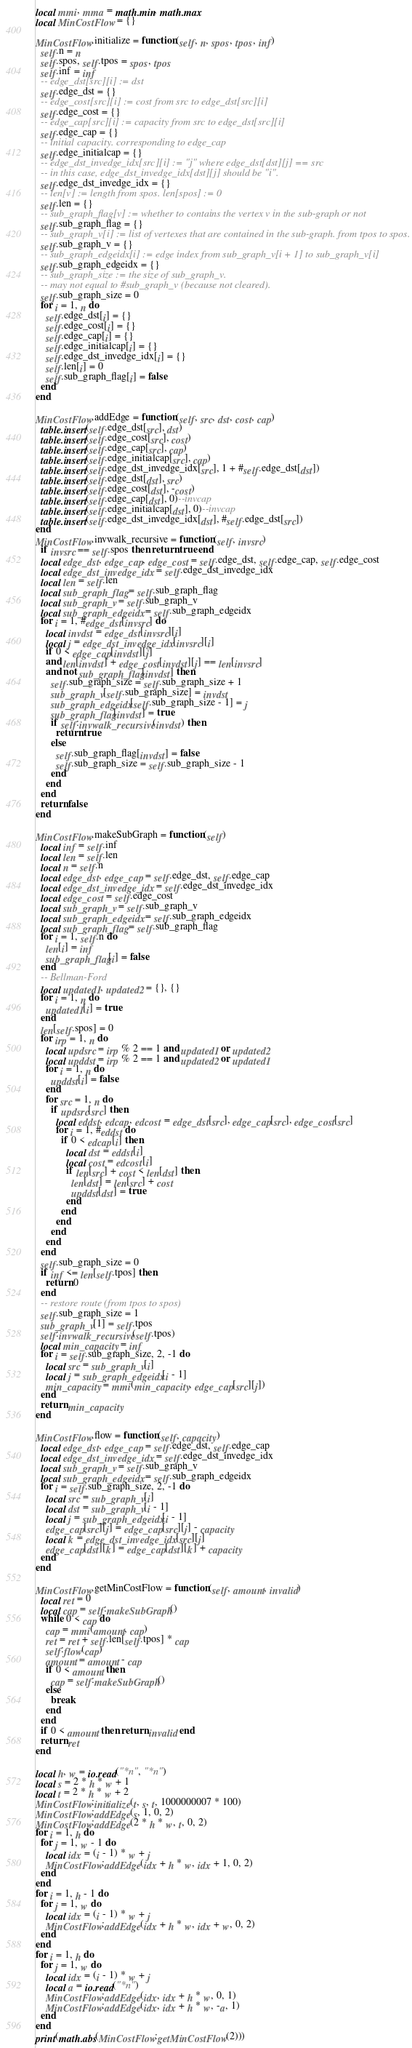<code> <loc_0><loc_0><loc_500><loc_500><_Lua_>local mmi, mma = math.min, math.max
local MinCostFlow = {}

MinCostFlow.initialize = function(self, n, spos, tpos, inf)
  self.n = n
  self.spos, self.tpos = spos, tpos
  self.inf = inf
  -- edge_dst[src][i] := dst
  self.edge_dst = {}
  -- edge_cost[src][i] := cost from src to edge_dst[src][i]
  self.edge_cost = {}
  -- edge_cap[src][i] := capacity from src to edge_dst[src][i]
  self.edge_cap = {}
  -- initial capacity. corresponding to edge_cap
  self.edge_initialcap = {}
  -- edge_dst_invedge_idx[src][i] := "j" where edge_dst[dst][j] == src
  -- in this case, edge_dst_invedge_idx[dst][j] should be "i".
  self.edge_dst_invedge_idx = {}
  -- len[v] := length from spos. len[spos] := 0
  self.len = {}
  -- sub_graph_flag[v] := whether to contains the vertex v in the sub-graph or not
  self.sub_graph_flag = {}
  -- sub_graph_v[i] := list of vertexes that are contained in the sub-graph. from tpos to spos.
  self.sub_graph_v = {}
  -- sub_graph_edgeidx[i] := edge index from sub_graph_v[i + 1] to sub_graph_v[i]
  self.sub_graph_edgeidx = {}
  -- sub_graph_size := the size of sub_graph_v.
  -- may not equal to #sub_graph_v (because not cleared).
  self.sub_graph_size = 0
  for i = 1, n do
    self.edge_dst[i] = {}
    self.edge_cost[i] = {}
    self.edge_cap[i] = {}
    self.edge_initialcap[i] = {}
    self.edge_dst_invedge_idx[i] = {}
    self.len[i] = 0
    self.sub_graph_flag[i] = false
  end
end

MinCostFlow.addEdge = function(self, src, dst, cost, cap)
  table.insert(self.edge_dst[src], dst)
  table.insert(self.edge_cost[src], cost)
  table.insert(self.edge_cap[src], cap)
  table.insert(self.edge_initialcap[src], cap)
  table.insert(self.edge_dst_invedge_idx[src], 1 + #self.edge_dst[dst])
  table.insert(self.edge_dst[dst], src)
  table.insert(self.edge_cost[dst], -cost)
  table.insert(self.edge_cap[dst], 0)--invcap
  table.insert(self.edge_initialcap[dst], 0)--invcap
  table.insert(self.edge_dst_invedge_idx[dst], #self.edge_dst[src])
end
MinCostFlow.invwalk_recursive = function(self, invsrc)
  if invsrc == self.spos then return true end
  local edge_dst, edge_cap, edge_cost = self.edge_dst, self.edge_cap, self.edge_cost
  local edge_dst_invedge_idx = self.edge_dst_invedge_idx
  local len = self.len
  local sub_graph_flag = self.sub_graph_flag
  local sub_graph_v = self.sub_graph_v
  local sub_graph_edgeidx = self.sub_graph_edgeidx
  for i = 1, #edge_dst[invsrc] do
    local invdst = edge_dst[invsrc][i]
    local j = edge_dst_invedge_idx[invsrc][i]
    if 0 < edge_cap[invdst][j]
    and len[invdst] + edge_cost[invdst][j] == len[invsrc]
    and not sub_graph_flag[invdst] then
      self.sub_graph_size = self.sub_graph_size + 1
      sub_graph_v[self.sub_graph_size] = invdst
      sub_graph_edgeidx[self.sub_graph_size - 1] = j
      sub_graph_flag[invdst] = true
      if self:invwalk_recursive(invdst) then
        return true
      else
        self.sub_graph_flag[invdst] = false
        self.sub_graph_size = self.sub_graph_size - 1
      end
    end
  end
  return false
end

MinCostFlow.makeSubGraph = function(self)
  local inf = self.inf
  local len = self.len
  local n = self.n
  local edge_dst, edge_cap = self.edge_dst, self.edge_cap
  local edge_dst_invedge_idx = self.edge_dst_invedge_idx
  local edge_cost = self.edge_cost
  local sub_graph_v = self.sub_graph_v
  local sub_graph_edgeidx = self.sub_graph_edgeidx
  local sub_graph_flag = self.sub_graph_flag
  for i = 1, self.n do
    len[i] = inf
    sub_graph_flag[i] = false
  end
  -- Bellman-Ford
  local updated1, updated2 = {}, {}
  for i = 1, n do
    updated1[i] = true
  end
  len[self.spos] = 0
  for irp = 1, n do
    local updsrc = irp % 2 == 1 and updated1 or updated2
    local upddst = irp % 2 == 1 and updated2 or updated1
    for i = 1, n do
      upddst[i] = false
    end
    for src = 1, n do
      if updsrc[src] then
        local eddst, edcap, edcost = edge_dst[src], edge_cap[src], edge_cost[src]
        for i = 1, #eddst do
          if 0 < edcap[i] then
            local dst = eddst[i]
            local cost = edcost[i]
            if len[src] + cost < len[dst] then
              len[dst] = len[src] + cost
              upddst[dst] = true
            end
          end
        end
      end
    end
  end
  self.sub_graph_size = 0
  if inf <= len[self.tpos] then
    return 0
  end
  -- restore route (from tpos to spos)
  self.sub_graph_size = 1
  sub_graph_v[1] = self.tpos
  self:invwalk_recursive(self.tpos)
  local min_capacity = inf
  for i = self.sub_graph_size, 2, -1 do
    local src = sub_graph_v[i]
    local j = sub_graph_edgeidx[i - 1]
    min_capacity = mmi(min_capacity, edge_cap[src][j])
  end
  return min_capacity
end

MinCostFlow.flow = function(self, capacity)
  local edge_dst, edge_cap = self.edge_dst, self.edge_cap
  local edge_dst_invedge_idx = self.edge_dst_invedge_idx
  local sub_graph_v = self.sub_graph_v
  local sub_graph_edgeidx = self.sub_graph_edgeidx
  for i = self.sub_graph_size, 2, -1 do
    local src = sub_graph_v[i]
    local dst = sub_graph_v[i - 1]
    local j = sub_graph_edgeidx[i - 1]
    edge_cap[src][j] = edge_cap[src][j] - capacity
    local k = edge_dst_invedge_idx[src][j]
    edge_cap[dst][k] = edge_cap[dst][k] + capacity
  end
end

MinCostFlow.getMinCostFlow = function(self, amount, invalid)
  local ret = 0
  local cap = self:makeSubGraph()
  while 0 < cap do
    cap = mmi(amount, cap)
    ret = ret + self.len[self.tpos] * cap
    self:flow(cap)
    amount = amount - cap
    if 0 < amount then
      cap = self:makeSubGraph()
    else
      break
    end
  end
  if 0 < amount then return invalid end
  return ret
end

local h, w = io.read("*n", "*n")
local s = 2 * h * w + 1
local t = 2 * h * w + 2
MinCostFlow:initialize(t, s, t, 1000000007 * 100)
MinCostFlow:addEdge(s, 1, 0, 2)
MinCostFlow:addEdge(2 * h * w, t, 0, 2)
for i = 1, h do
  for j = 1, w - 1 do
    local idx = (i - 1) * w + j
    MinCostFlow:addEdge(idx + h * w, idx + 1, 0, 2)
  end
end
for i = 1, h - 1 do
  for j = 1, w do
    local idx = (i - 1) * w + j
    MinCostFlow:addEdge(idx + h * w, idx + w, 0, 2)
  end
end
for i = 1, h do
  for j = 1, w do
    local idx = (i - 1) * w + j
    local a = io.read("*n")
    MinCostFlow:addEdge(idx, idx + h * w, 0, 1)
    MinCostFlow:addEdge(idx, idx + h * w, -a, 1)
  end
end
print(math.abs(MinCostFlow:getMinCostFlow(2)))
</code> 